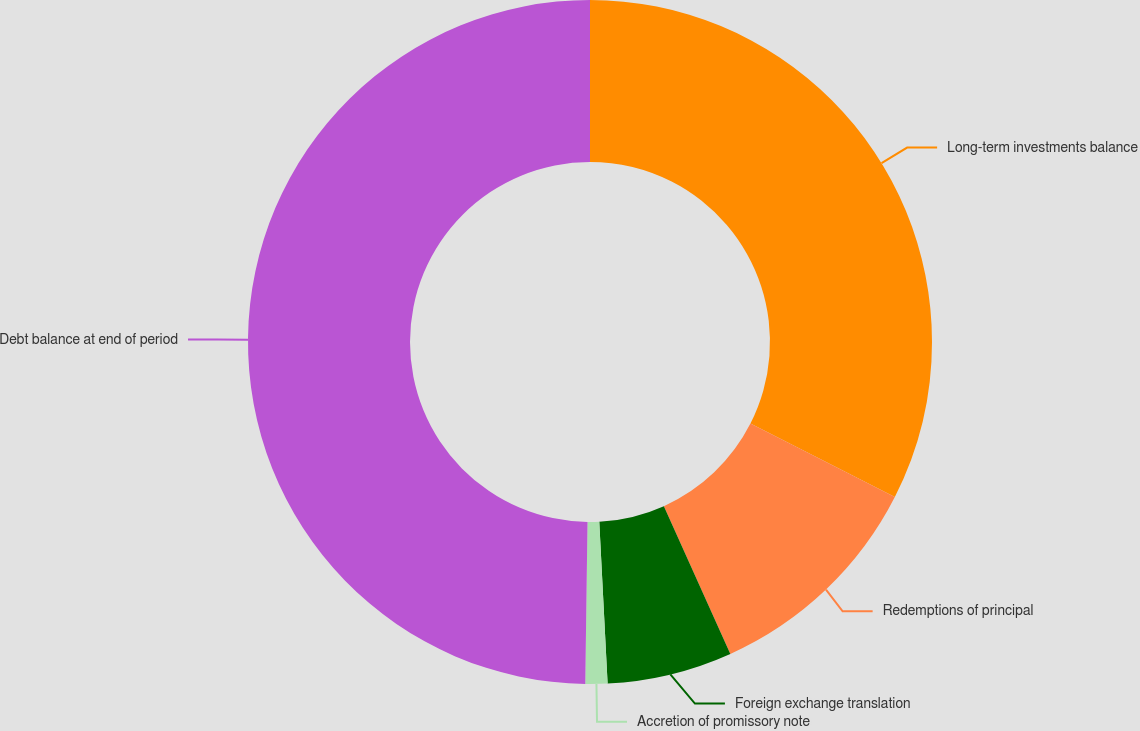<chart> <loc_0><loc_0><loc_500><loc_500><pie_chart><fcel>Long-term investments balance<fcel>Redemptions of principal<fcel>Foreign exchange translation<fcel>Accretion of promissory note<fcel>Debt balance at end of period<nl><fcel>32.49%<fcel>10.78%<fcel>5.91%<fcel>1.04%<fcel>49.78%<nl></chart> 